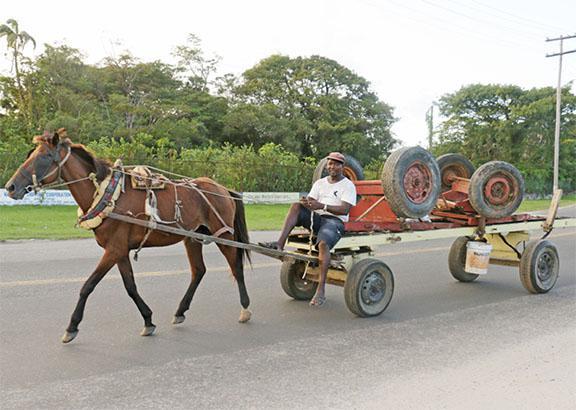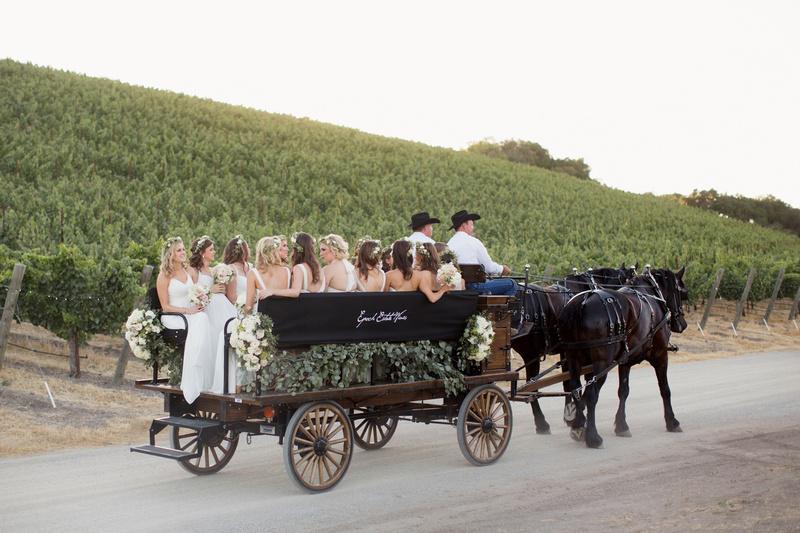The first image is the image on the left, the second image is the image on the right. For the images shown, is this caption "The wheels on each of the carts are spoked wooden ones ." true? Answer yes or no. No. The first image is the image on the left, the second image is the image on the right. Examine the images to the left and right. Is the description "An image shows at least one member of a wedding party in the back of a four-wheeled carriage heading away from the camera." accurate? Answer yes or no. Yes. 